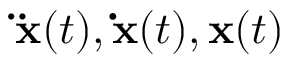<formula> <loc_0><loc_0><loc_500><loc_500>\ddot { x } ( t ) , \dot { x } ( t ) , x ( t )</formula> 